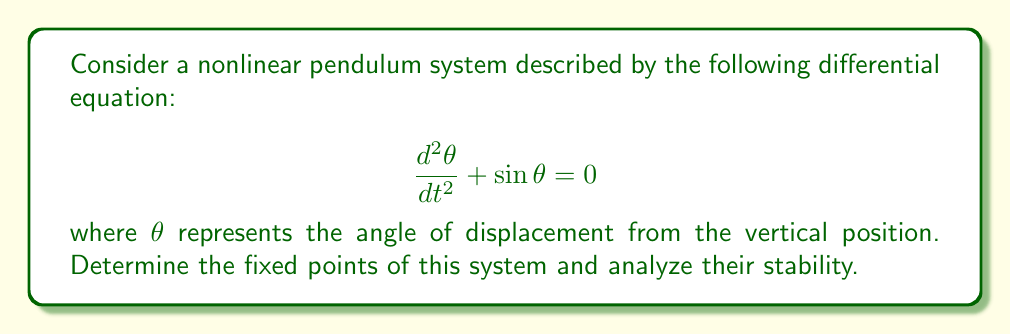Give your solution to this math problem. To solve this problem, we'll follow these steps:

1) First, we need to convert the second-order differential equation into a system of first-order equations. Let $x_1 = \theta$ and $x_2 = \frac{d\theta}{dt}$. Then:

   $$\frac{dx_1}{dt} = x_2$$
   $$\frac{dx_2}{dt} = -\sin x_1$$

2) To find the fixed points, we set both derivatives to zero:

   $$x_2 = 0$$
   $$-\sin x_1 = 0$$

3) From $\sin x_1 = 0$, we get $x_1 = n\pi$, where $n$ is any integer. This gives us two distinct fixed points:
   
   $(0, 0)$ and $(\pi, 0)$

4) To analyze stability, we need to linearize the system around each fixed point. The Jacobian matrix is:

   $$J = \begin{bmatrix}
   0 & 1 \\
   -\cos x_1 & 0
   \end{bmatrix}$$

5) For the fixed point $(0, 0)$:
   
   $$J_{(0,0)} = \begin{bmatrix}
   0 & 1 \\
   -1 & 0
   \end{bmatrix}$$

   The eigenvalues are $\lambda = \pm i$. Since they are purely imaginary, this fixed point is a center and is neutrally stable.

6) For the fixed point $(\pi, 0)$:
   
   $$J_{(\pi,0)} = \begin{bmatrix}
   0 & 1 \\
   1 & 0
   \end{bmatrix}$$

   The eigenvalues are $\lambda = \pm 1$. Since one eigenvalue is positive, this fixed point is a saddle point and is unstable.
Answer: Fixed points: $(0, 0)$ (center, neutrally stable) and $(\pi, 0)$ (saddle, unstable). 